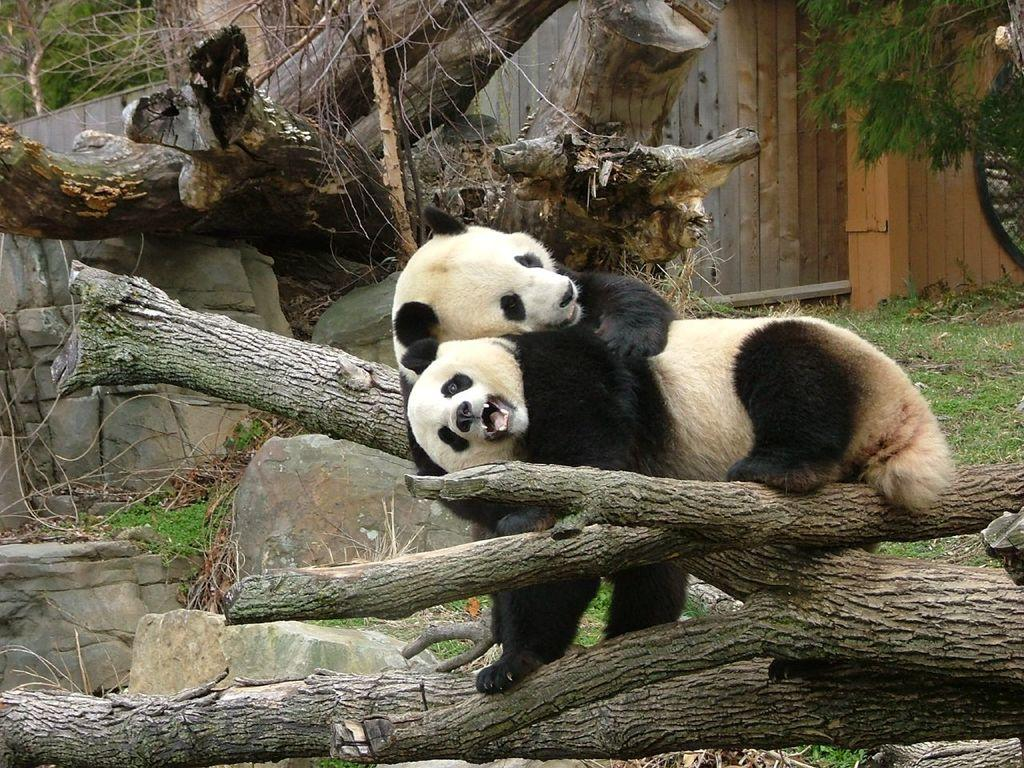What animals are present in the image? There are pandas in the image. Where are the pandas located? The pandas are on a log. What can be seen in the background of the image? There are trees and a fence in the background of the image. What type of vegetation is visible at the bottom of the image? There is grass at the bottom of the image. What color is the crayon being used by the pandas in the image? There is no crayon present in the image; the pandas are on a log and not using any drawing materials. 